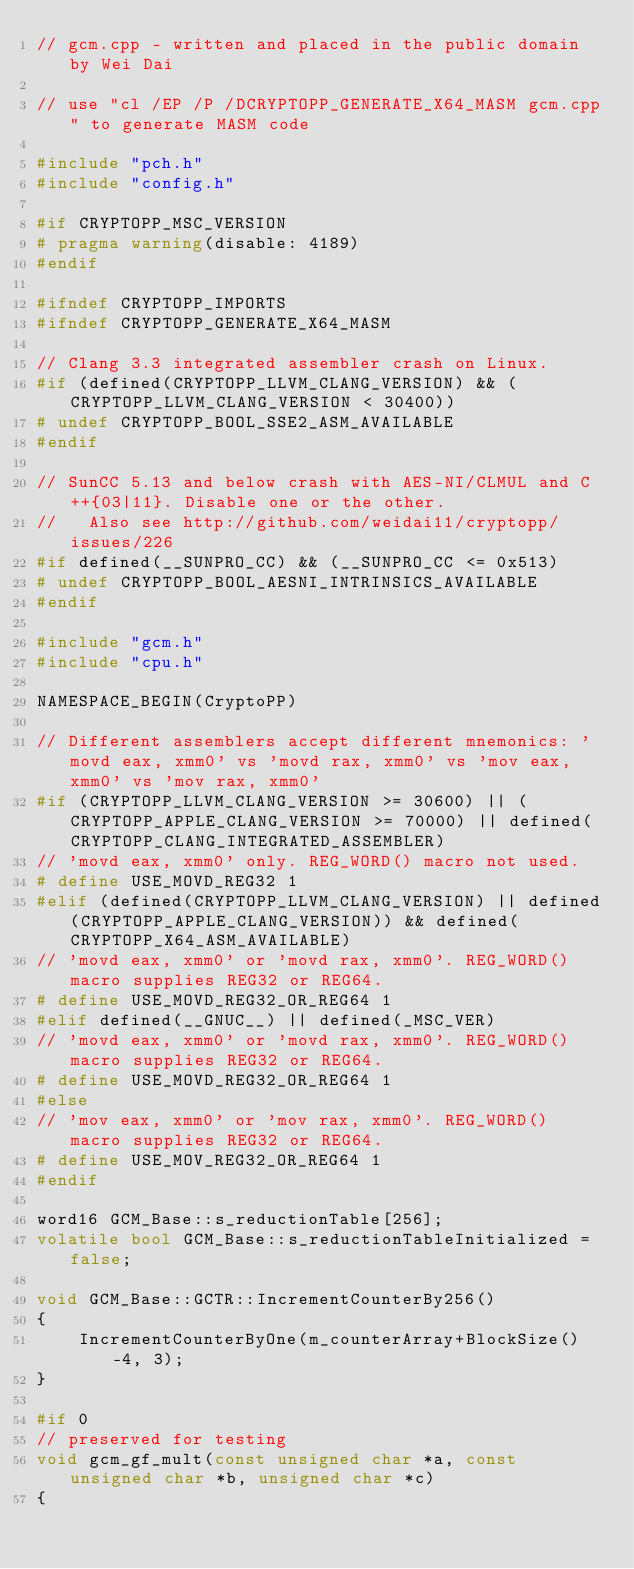<code> <loc_0><loc_0><loc_500><loc_500><_C++_>// gcm.cpp - written and placed in the public domain by Wei Dai

// use "cl /EP /P /DCRYPTOPP_GENERATE_X64_MASM gcm.cpp" to generate MASM code

#include "pch.h"
#include "config.h"

#if CRYPTOPP_MSC_VERSION
# pragma warning(disable: 4189)
#endif

#ifndef CRYPTOPP_IMPORTS
#ifndef CRYPTOPP_GENERATE_X64_MASM

// Clang 3.3 integrated assembler crash on Linux.
#if (defined(CRYPTOPP_LLVM_CLANG_VERSION) && (CRYPTOPP_LLVM_CLANG_VERSION < 30400))
# undef CRYPTOPP_BOOL_SSE2_ASM_AVAILABLE
#endif

// SunCC 5.13 and below crash with AES-NI/CLMUL and C++{03|11}. Disable one or the other.
//   Also see http://github.com/weidai11/cryptopp/issues/226
#if defined(__SUNPRO_CC) && (__SUNPRO_CC <= 0x513)
# undef CRYPTOPP_BOOL_AESNI_INTRINSICS_AVAILABLE
#endif

#include "gcm.h"
#include "cpu.h"

NAMESPACE_BEGIN(CryptoPP)

// Different assemblers accept different mnemonics: 'movd eax, xmm0' vs 'movd rax, xmm0' vs 'mov eax, xmm0' vs 'mov rax, xmm0'
#if (CRYPTOPP_LLVM_CLANG_VERSION >= 30600) || (CRYPTOPP_APPLE_CLANG_VERSION >= 70000) || defined(CRYPTOPP_CLANG_INTEGRATED_ASSEMBLER)
// 'movd eax, xmm0' only. REG_WORD() macro not used.
# define USE_MOVD_REG32 1
#elif (defined(CRYPTOPP_LLVM_CLANG_VERSION) || defined(CRYPTOPP_APPLE_CLANG_VERSION)) && defined(CRYPTOPP_X64_ASM_AVAILABLE)
// 'movd eax, xmm0' or 'movd rax, xmm0'. REG_WORD() macro supplies REG32 or REG64.
# define USE_MOVD_REG32_OR_REG64 1
#elif defined(__GNUC__) || defined(_MSC_VER)
// 'movd eax, xmm0' or 'movd rax, xmm0'. REG_WORD() macro supplies REG32 or REG64.
# define USE_MOVD_REG32_OR_REG64 1
#else
// 'mov eax, xmm0' or 'mov rax, xmm0'. REG_WORD() macro supplies REG32 or REG64.
# define USE_MOV_REG32_OR_REG64 1
#endif

word16 GCM_Base::s_reductionTable[256];
volatile bool GCM_Base::s_reductionTableInitialized = false;

void GCM_Base::GCTR::IncrementCounterBy256()
{
	IncrementCounterByOne(m_counterArray+BlockSize()-4, 3);
}

#if 0
// preserved for testing
void gcm_gf_mult(const unsigned char *a, const unsigned char *b, unsigned char *c)
{</code> 